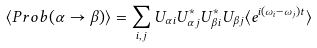Convert formula to latex. <formula><loc_0><loc_0><loc_500><loc_500>\langle P r o b ( \alpha \rightarrow \beta ) \rangle = \sum _ { i , j } U _ { \alpha i } U ^ { * } _ { \alpha j } U _ { \beta i } ^ { * } U _ { \beta j } \langle e ^ { i ( \omega _ { i } - \omega _ { j } ) t } \rangle</formula> 